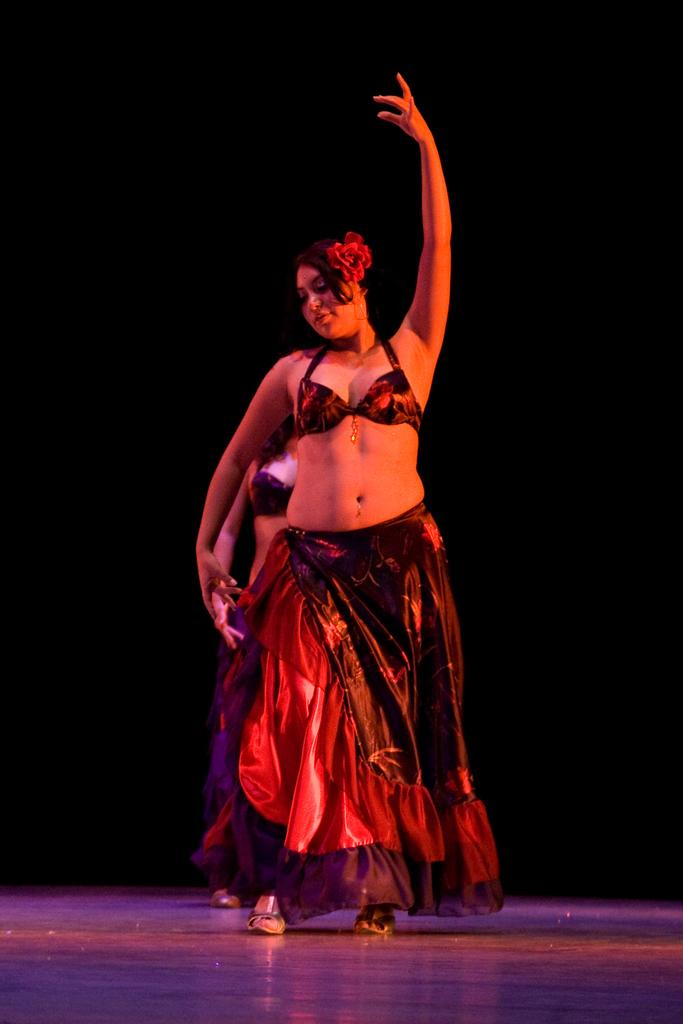How many people are in the image? There are two girls in the image. What are the girls doing in the image? The girls are dancing on the floor. What can be observed about the background of the image? The background of the image is dark. What type of trucks can be seen in the background of the image? There are no trucks present in the image; the background is dark. Who is the uncle in the image? There is no uncle present in the image; it features two girls dancing. 